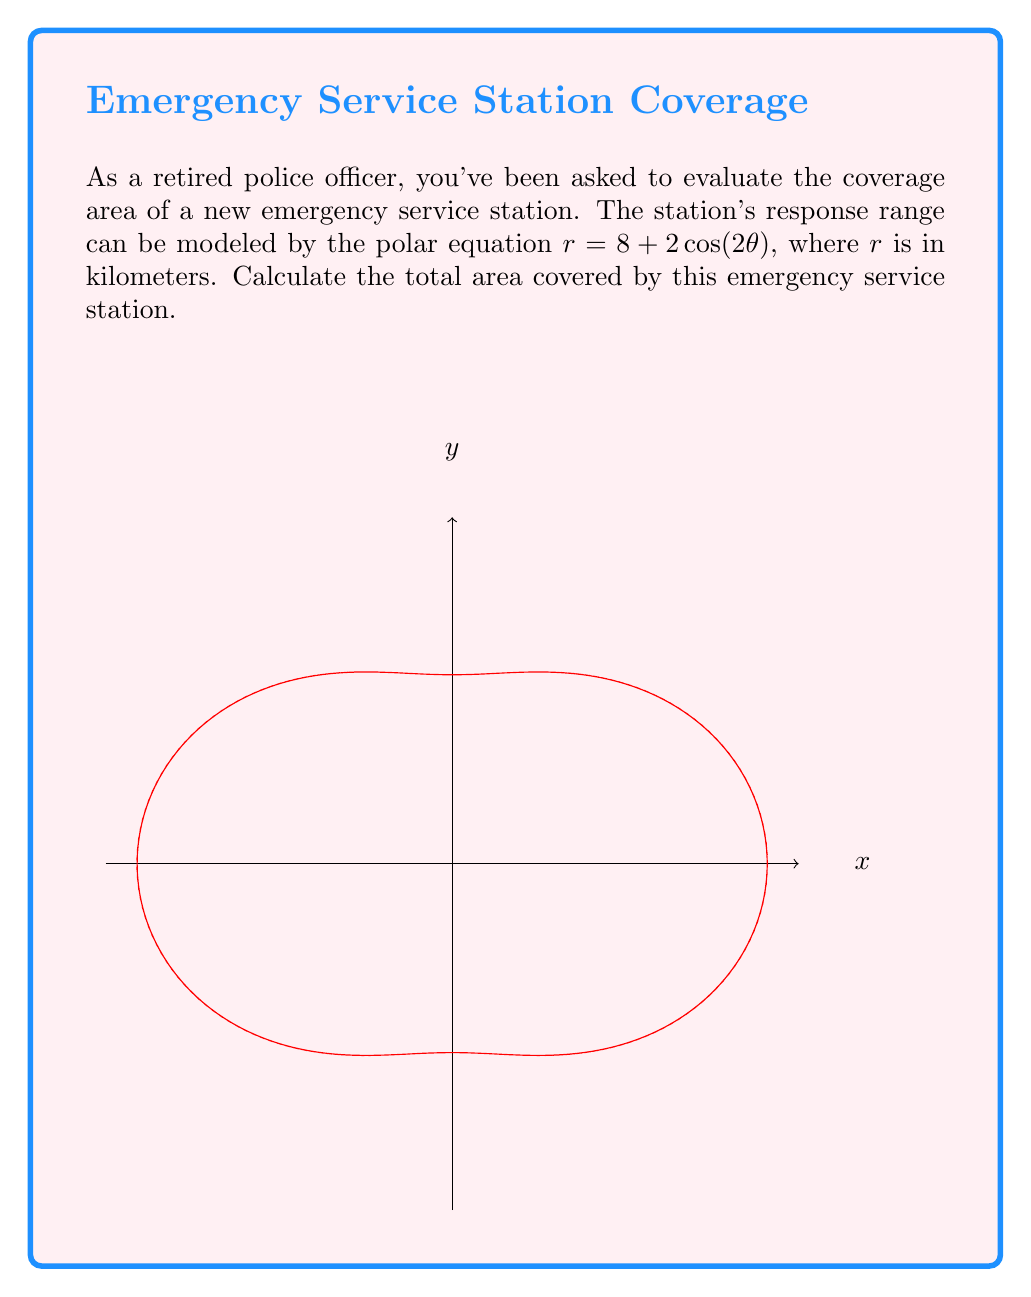Can you answer this question? To find the area enclosed by a polar curve, we use the formula:

$$A = \frac{1}{2} \int_0^{2\pi} r^2(\theta) d\theta$$

Here, $r(\theta) = 8 + 2\cos(2\theta)$. We need to square this function:

$$r^2(\theta) = (8 + 2\cos(2\theta))^2 = 64 + 32\cos(2\theta) + 4\cos^2(2\theta)$$

Now, let's substitute this into our area formula:

$$A = \frac{1}{2} \int_0^{2\pi} (64 + 32\cos(2\theta) + 4\cos^2(2\theta)) d\theta$$

We can split this integral:

$$A = \frac{1}{2} \left[ 64 \int_0^{2\pi} d\theta + 32 \int_0^{2\pi} \cos(2\theta) d\theta + 4 \int_0^{2\pi} \cos^2(2\theta) d\theta \right]$$

Evaluating each integral:
1. $\int_0^{2\pi} d\theta = 2\pi$
2. $\int_0^{2\pi} \cos(2\theta) d\theta = 0$ (cosine integrates to zero over a full period)
3. $\int_0^{2\pi} \cos^2(2\theta) d\theta = \pi$ (half-angle formula for cosine squared)

Substituting these results:

$$A = \frac{1}{2} [64(2\pi) + 32(0) + 4(\pi)] = 32\pi + 2\pi = 34\pi$$

Therefore, the total area covered by the emergency service station is $34\pi$ square kilometers.
Answer: $34\pi$ km² 